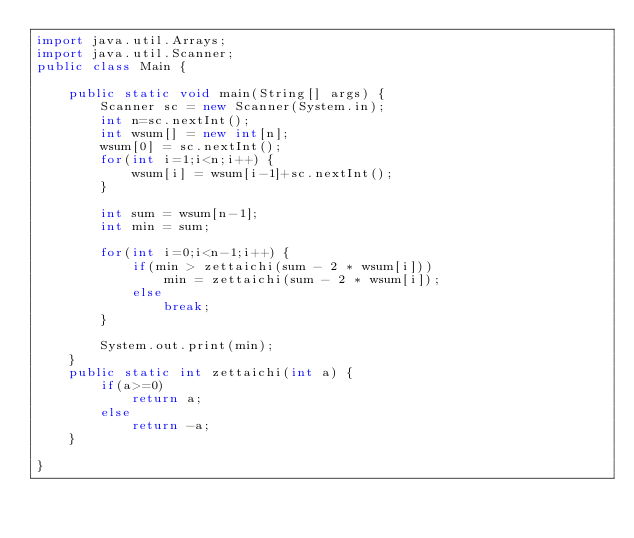<code> <loc_0><loc_0><loc_500><loc_500><_Java_>import java.util.Arrays;
import java.util.Scanner;
public class Main {

	public static void main(String[] args) {
		Scanner sc = new Scanner(System.in);
		int n=sc.nextInt();
		int wsum[] = new int[n];
		wsum[0] = sc.nextInt();
		for(int i=1;i<n;i++) {
			wsum[i] = wsum[i-1]+sc.nextInt();
		}
		
		int sum = wsum[n-1];
		int min = sum;
		
		for(int i=0;i<n-1;i++) {
			if(min > zettaichi(sum - 2 * wsum[i]))
				min = zettaichi(sum - 2 * wsum[i]);
			else
				break;
		}
		
		System.out.print(min);
	}
	public static int zettaichi(int a) {
		if(a>=0)
			return a;
		else
			return -a;
	}
	
}</code> 